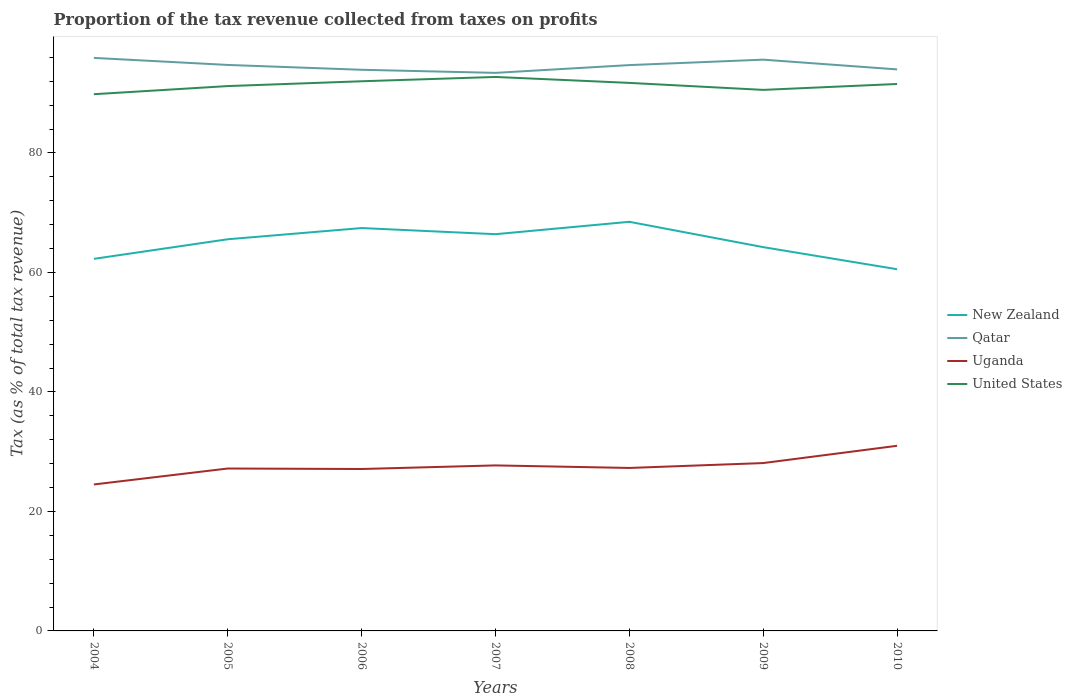How many different coloured lines are there?
Keep it short and to the point. 4. Does the line corresponding to Uganda intersect with the line corresponding to New Zealand?
Make the answer very short. No. Across all years, what is the maximum proportion of the tax revenue collected in Uganda?
Your answer should be very brief. 24.51. What is the total proportion of the tax revenue collected in New Zealand in the graph?
Your answer should be very brief. 1.32. What is the difference between the highest and the second highest proportion of the tax revenue collected in New Zealand?
Make the answer very short. 7.94. What is the difference between the highest and the lowest proportion of the tax revenue collected in Qatar?
Offer a very short reply. 4. How many lines are there?
Provide a short and direct response. 4. How many years are there in the graph?
Ensure brevity in your answer.  7. What is the difference between two consecutive major ticks on the Y-axis?
Offer a terse response. 20. Are the values on the major ticks of Y-axis written in scientific E-notation?
Your answer should be very brief. No. Does the graph contain any zero values?
Your answer should be compact. No. Does the graph contain grids?
Give a very brief answer. No. Where does the legend appear in the graph?
Make the answer very short. Center right. What is the title of the graph?
Ensure brevity in your answer.  Proportion of the tax revenue collected from taxes on profits. Does "Timor-Leste" appear as one of the legend labels in the graph?
Give a very brief answer. No. What is the label or title of the Y-axis?
Your answer should be compact. Tax (as % of total tax revenue). What is the Tax (as % of total tax revenue) in New Zealand in 2004?
Offer a terse response. 62.27. What is the Tax (as % of total tax revenue) in Qatar in 2004?
Keep it short and to the point. 95.9. What is the Tax (as % of total tax revenue) of Uganda in 2004?
Your response must be concise. 24.51. What is the Tax (as % of total tax revenue) of United States in 2004?
Give a very brief answer. 89.83. What is the Tax (as % of total tax revenue) of New Zealand in 2005?
Offer a very short reply. 65.55. What is the Tax (as % of total tax revenue) in Qatar in 2005?
Ensure brevity in your answer.  94.73. What is the Tax (as % of total tax revenue) of Uganda in 2005?
Keep it short and to the point. 27.18. What is the Tax (as % of total tax revenue) in United States in 2005?
Ensure brevity in your answer.  91.19. What is the Tax (as % of total tax revenue) in New Zealand in 2006?
Ensure brevity in your answer.  67.43. What is the Tax (as % of total tax revenue) in Qatar in 2006?
Your response must be concise. 93.92. What is the Tax (as % of total tax revenue) of Uganda in 2006?
Offer a very short reply. 27.1. What is the Tax (as % of total tax revenue) of United States in 2006?
Make the answer very short. 91.99. What is the Tax (as % of total tax revenue) in New Zealand in 2007?
Provide a short and direct response. 66.4. What is the Tax (as % of total tax revenue) of Qatar in 2007?
Give a very brief answer. 93.4. What is the Tax (as % of total tax revenue) of Uganda in 2007?
Give a very brief answer. 27.7. What is the Tax (as % of total tax revenue) in United States in 2007?
Give a very brief answer. 92.71. What is the Tax (as % of total tax revenue) in New Zealand in 2008?
Keep it short and to the point. 68.47. What is the Tax (as % of total tax revenue) in Qatar in 2008?
Ensure brevity in your answer.  94.7. What is the Tax (as % of total tax revenue) of Uganda in 2008?
Offer a very short reply. 27.27. What is the Tax (as % of total tax revenue) of United States in 2008?
Your response must be concise. 91.72. What is the Tax (as % of total tax revenue) of New Zealand in 2009?
Ensure brevity in your answer.  64.23. What is the Tax (as % of total tax revenue) of Qatar in 2009?
Your answer should be very brief. 95.61. What is the Tax (as % of total tax revenue) in Uganda in 2009?
Provide a short and direct response. 28.09. What is the Tax (as % of total tax revenue) in United States in 2009?
Offer a very short reply. 90.55. What is the Tax (as % of total tax revenue) in New Zealand in 2010?
Your response must be concise. 60.53. What is the Tax (as % of total tax revenue) in Qatar in 2010?
Provide a short and direct response. 93.98. What is the Tax (as % of total tax revenue) in Uganda in 2010?
Your answer should be very brief. 30.98. What is the Tax (as % of total tax revenue) in United States in 2010?
Keep it short and to the point. 91.54. Across all years, what is the maximum Tax (as % of total tax revenue) of New Zealand?
Offer a very short reply. 68.47. Across all years, what is the maximum Tax (as % of total tax revenue) of Qatar?
Provide a short and direct response. 95.9. Across all years, what is the maximum Tax (as % of total tax revenue) of Uganda?
Your answer should be very brief. 30.98. Across all years, what is the maximum Tax (as % of total tax revenue) in United States?
Make the answer very short. 92.71. Across all years, what is the minimum Tax (as % of total tax revenue) in New Zealand?
Your answer should be compact. 60.53. Across all years, what is the minimum Tax (as % of total tax revenue) in Qatar?
Give a very brief answer. 93.4. Across all years, what is the minimum Tax (as % of total tax revenue) of Uganda?
Your answer should be compact. 24.51. Across all years, what is the minimum Tax (as % of total tax revenue) in United States?
Your answer should be very brief. 89.83. What is the total Tax (as % of total tax revenue) of New Zealand in the graph?
Offer a very short reply. 454.89. What is the total Tax (as % of total tax revenue) in Qatar in the graph?
Provide a short and direct response. 662.24. What is the total Tax (as % of total tax revenue) in Uganda in the graph?
Your answer should be very brief. 192.85. What is the total Tax (as % of total tax revenue) in United States in the graph?
Your answer should be compact. 639.54. What is the difference between the Tax (as % of total tax revenue) in New Zealand in 2004 and that in 2005?
Your answer should be compact. -3.28. What is the difference between the Tax (as % of total tax revenue) of Qatar in 2004 and that in 2005?
Ensure brevity in your answer.  1.18. What is the difference between the Tax (as % of total tax revenue) of Uganda in 2004 and that in 2005?
Offer a terse response. -2.67. What is the difference between the Tax (as % of total tax revenue) in United States in 2004 and that in 2005?
Make the answer very short. -1.36. What is the difference between the Tax (as % of total tax revenue) in New Zealand in 2004 and that in 2006?
Your answer should be compact. -5.15. What is the difference between the Tax (as % of total tax revenue) in Qatar in 2004 and that in 2006?
Keep it short and to the point. 1.99. What is the difference between the Tax (as % of total tax revenue) in Uganda in 2004 and that in 2006?
Offer a very short reply. -2.59. What is the difference between the Tax (as % of total tax revenue) in United States in 2004 and that in 2006?
Give a very brief answer. -2.17. What is the difference between the Tax (as % of total tax revenue) in New Zealand in 2004 and that in 2007?
Offer a terse response. -4.13. What is the difference between the Tax (as % of total tax revenue) in Qatar in 2004 and that in 2007?
Your answer should be very brief. 2.5. What is the difference between the Tax (as % of total tax revenue) in Uganda in 2004 and that in 2007?
Your answer should be very brief. -3.19. What is the difference between the Tax (as % of total tax revenue) in United States in 2004 and that in 2007?
Your answer should be compact. -2.89. What is the difference between the Tax (as % of total tax revenue) of New Zealand in 2004 and that in 2008?
Provide a short and direct response. -6.2. What is the difference between the Tax (as % of total tax revenue) in Qatar in 2004 and that in 2008?
Give a very brief answer. 1.2. What is the difference between the Tax (as % of total tax revenue) of Uganda in 2004 and that in 2008?
Provide a short and direct response. -2.76. What is the difference between the Tax (as % of total tax revenue) in United States in 2004 and that in 2008?
Give a very brief answer. -1.89. What is the difference between the Tax (as % of total tax revenue) of New Zealand in 2004 and that in 2009?
Offer a terse response. -1.96. What is the difference between the Tax (as % of total tax revenue) in Qatar in 2004 and that in 2009?
Your answer should be compact. 0.29. What is the difference between the Tax (as % of total tax revenue) in Uganda in 2004 and that in 2009?
Provide a short and direct response. -3.58. What is the difference between the Tax (as % of total tax revenue) of United States in 2004 and that in 2009?
Give a very brief answer. -0.72. What is the difference between the Tax (as % of total tax revenue) of New Zealand in 2004 and that in 2010?
Provide a short and direct response. 1.74. What is the difference between the Tax (as % of total tax revenue) of Qatar in 2004 and that in 2010?
Your response must be concise. 1.92. What is the difference between the Tax (as % of total tax revenue) in Uganda in 2004 and that in 2010?
Offer a terse response. -6.47. What is the difference between the Tax (as % of total tax revenue) of United States in 2004 and that in 2010?
Make the answer very short. -1.71. What is the difference between the Tax (as % of total tax revenue) of New Zealand in 2005 and that in 2006?
Your answer should be compact. -1.88. What is the difference between the Tax (as % of total tax revenue) of Qatar in 2005 and that in 2006?
Your response must be concise. 0.81. What is the difference between the Tax (as % of total tax revenue) in Uganda in 2005 and that in 2006?
Your response must be concise. 0.08. What is the difference between the Tax (as % of total tax revenue) of United States in 2005 and that in 2006?
Provide a succinct answer. -0.81. What is the difference between the Tax (as % of total tax revenue) in New Zealand in 2005 and that in 2007?
Make the answer very short. -0.85. What is the difference between the Tax (as % of total tax revenue) in Qatar in 2005 and that in 2007?
Offer a terse response. 1.33. What is the difference between the Tax (as % of total tax revenue) in Uganda in 2005 and that in 2007?
Your answer should be compact. -0.52. What is the difference between the Tax (as % of total tax revenue) in United States in 2005 and that in 2007?
Give a very brief answer. -1.53. What is the difference between the Tax (as % of total tax revenue) of New Zealand in 2005 and that in 2008?
Make the answer very short. -2.92. What is the difference between the Tax (as % of total tax revenue) in Qatar in 2005 and that in 2008?
Your response must be concise. 0.03. What is the difference between the Tax (as % of total tax revenue) of Uganda in 2005 and that in 2008?
Ensure brevity in your answer.  -0.09. What is the difference between the Tax (as % of total tax revenue) of United States in 2005 and that in 2008?
Keep it short and to the point. -0.53. What is the difference between the Tax (as % of total tax revenue) of New Zealand in 2005 and that in 2009?
Make the answer very short. 1.32. What is the difference between the Tax (as % of total tax revenue) in Qatar in 2005 and that in 2009?
Provide a short and direct response. -0.88. What is the difference between the Tax (as % of total tax revenue) in Uganda in 2005 and that in 2009?
Keep it short and to the point. -0.91. What is the difference between the Tax (as % of total tax revenue) in United States in 2005 and that in 2009?
Your answer should be compact. 0.64. What is the difference between the Tax (as % of total tax revenue) in New Zealand in 2005 and that in 2010?
Provide a succinct answer. 5.02. What is the difference between the Tax (as % of total tax revenue) of Qatar in 2005 and that in 2010?
Your answer should be compact. 0.75. What is the difference between the Tax (as % of total tax revenue) of Uganda in 2005 and that in 2010?
Provide a succinct answer. -3.8. What is the difference between the Tax (as % of total tax revenue) of United States in 2005 and that in 2010?
Your answer should be compact. -0.35. What is the difference between the Tax (as % of total tax revenue) in New Zealand in 2006 and that in 2007?
Your answer should be compact. 1.03. What is the difference between the Tax (as % of total tax revenue) of Qatar in 2006 and that in 2007?
Offer a very short reply. 0.52. What is the difference between the Tax (as % of total tax revenue) of Uganda in 2006 and that in 2007?
Make the answer very short. -0.6. What is the difference between the Tax (as % of total tax revenue) in United States in 2006 and that in 2007?
Your answer should be very brief. -0.72. What is the difference between the Tax (as % of total tax revenue) of New Zealand in 2006 and that in 2008?
Provide a succinct answer. -1.05. What is the difference between the Tax (as % of total tax revenue) in Qatar in 2006 and that in 2008?
Ensure brevity in your answer.  -0.78. What is the difference between the Tax (as % of total tax revenue) in Uganda in 2006 and that in 2008?
Give a very brief answer. -0.17. What is the difference between the Tax (as % of total tax revenue) in United States in 2006 and that in 2008?
Your answer should be compact. 0.27. What is the difference between the Tax (as % of total tax revenue) in New Zealand in 2006 and that in 2009?
Give a very brief answer. 3.19. What is the difference between the Tax (as % of total tax revenue) of Qatar in 2006 and that in 2009?
Make the answer very short. -1.69. What is the difference between the Tax (as % of total tax revenue) in Uganda in 2006 and that in 2009?
Make the answer very short. -0.99. What is the difference between the Tax (as % of total tax revenue) in United States in 2006 and that in 2009?
Give a very brief answer. 1.44. What is the difference between the Tax (as % of total tax revenue) in New Zealand in 2006 and that in 2010?
Make the answer very short. 6.89. What is the difference between the Tax (as % of total tax revenue) in Qatar in 2006 and that in 2010?
Your answer should be compact. -0.06. What is the difference between the Tax (as % of total tax revenue) of Uganda in 2006 and that in 2010?
Your answer should be compact. -3.88. What is the difference between the Tax (as % of total tax revenue) of United States in 2006 and that in 2010?
Your answer should be very brief. 0.46. What is the difference between the Tax (as % of total tax revenue) in New Zealand in 2007 and that in 2008?
Ensure brevity in your answer.  -2.07. What is the difference between the Tax (as % of total tax revenue) of Qatar in 2007 and that in 2008?
Ensure brevity in your answer.  -1.3. What is the difference between the Tax (as % of total tax revenue) of Uganda in 2007 and that in 2008?
Offer a terse response. 0.43. What is the difference between the Tax (as % of total tax revenue) of United States in 2007 and that in 2008?
Provide a short and direct response. 0.99. What is the difference between the Tax (as % of total tax revenue) of New Zealand in 2007 and that in 2009?
Ensure brevity in your answer.  2.17. What is the difference between the Tax (as % of total tax revenue) in Qatar in 2007 and that in 2009?
Provide a short and direct response. -2.21. What is the difference between the Tax (as % of total tax revenue) of Uganda in 2007 and that in 2009?
Provide a succinct answer. -0.39. What is the difference between the Tax (as % of total tax revenue) of United States in 2007 and that in 2009?
Offer a very short reply. 2.16. What is the difference between the Tax (as % of total tax revenue) in New Zealand in 2007 and that in 2010?
Provide a short and direct response. 5.87. What is the difference between the Tax (as % of total tax revenue) of Qatar in 2007 and that in 2010?
Provide a short and direct response. -0.58. What is the difference between the Tax (as % of total tax revenue) in Uganda in 2007 and that in 2010?
Your answer should be compact. -3.28. What is the difference between the Tax (as % of total tax revenue) of United States in 2007 and that in 2010?
Offer a terse response. 1.18. What is the difference between the Tax (as % of total tax revenue) of New Zealand in 2008 and that in 2009?
Provide a succinct answer. 4.24. What is the difference between the Tax (as % of total tax revenue) of Qatar in 2008 and that in 2009?
Give a very brief answer. -0.91. What is the difference between the Tax (as % of total tax revenue) of Uganda in 2008 and that in 2009?
Your answer should be compact. -0.82. What is the difference between the Tax (as % of total tax revenue) in United States in 2008 and that in 2009?
Offer a very short reply. 1.17. What is the difference between the Tax (as % of total tax revenue) of New Zealand in 2008 and that in 2010?
Provide a short and direct response. 7.94. What is the difference between the Tax (as % of total tax revenue) in Qatar in 2008 and that in 2010?
Offer a terse response. 0.72. What is the difference between the Tax (as % of total tax revenue) of Uganda in 2008 and that in 2010?
Provide a succinct answer. -3.71. What is the difference between the Tax (as % of total tax revenue) of United States in 2008 and that in 2010?
Offer a very short reply. 0.18. What is the difference between the Tax (as % of total tax revenue) of New Zealand in 2009 and that in 2010?
Your answer should be very brief. 3.7. What is the difference between the Tax (as % of total tax revenue) in Qatar in 2009 and that in 2010?
Your answer should be very brief. 1.63. What is the difference between the Tax (as % of total tax revenue) in Uganda in 2009 and that in 2010?
Provide a short and direct response. -2.89. What is the difference between the Tax (as % of total tax revenue) of United States in 2009 and that in 2010?
Offer a terse response. -0.99. What is the difference between the Tax (as % of total tax revenue) of New Zealand in 2004 and the Tax (as % of total tax revenue) of Qatar in 2005?
Your response must be concise. -32.45. What is the difference between the Tax (as % of total tax revenue) of New Zealand in 2004 and the Tax (as % of total tax revenue) of Uganda in 2005?
Your response must be concise. 35.09. What is the difference between the Tax (as % of total tax revenue) of New Zealand in 2004 and the Tax (as % of total tax revenue) of United States in 2005?
Keep it short and to the point. -28.91. What is the difference between the Tax (as % of total tax revenue) of Qatar in 2004 and the Tax (as % of total tax revenue) of Uganda in 2005?
Provide a short and direct response. 68.72. What is the difference between the Tax (as % of total tax revenue) of Qatar in 2004 and the Tax (as % of total tax revenue) of United States in 2005?
Offer a terse response. 4.72. What is the difference between the Tax (as % of total tax revenue) in Uganda in 2004 and the Tax (as % of total tax revenue) in United States in 2005?
Offer a very short reply. -66.68. What is the difference between the Tax (as % of total tax revenue) in New Zealand in 2004 and the Tax (as % of total tax revenue) in Qatar in 2006?
Provide a succinct answer. -31.64. What is the difference between the Tax (as % of total tax revenue) of New Zealand in 2004 and the Tax (as % of total tax revenue) of Uganda in 2006?
Give a very brief answer. 35.17. What is the difference between the Tax (as % of total tax revenue) in New Zealand in 2004 and the Tax (as % of total tax revenue) in United States in 2006?
Offer a terse response. -29.72. What is the difference between the Tax (as % of total tax revenue) of Qatar in 2004 and the Tax (as % of total tax revenue) of Uganda in 2006?
Provide a succinct answer. 68.8. What is the difference between the Tax (as % of total tax revenue) in Qatar in 2004 and the Tax (as % of total tax revenue) in United States in 2006?
Give a very brief answer. 3.91. What is the difference between the Tax (as % of total tax revenue) in Uganda in 2004 and the Tax (as % of total tax revenue) in United States in 2006?
Your response must be concise. -67.48. What is the difference between the Tax (as % of total tax revenue) in New Zealand in 2004 and the Tax (as % of total tax revenue) in Qatar in 2007?
Provide a short and direct response. -31.13. What is the difference between the Tax (as % of total tax revenue) of New Zealand in 2004 and the Tax (as % of total tax revenue) of Uganda in 2007?
Your response must be concise. 34.57. What is the difference between the Tax (as % of total tax revenue) in New Zealand in 2004 and the Tax (as % of total tax revenue) in United States in 2007?
Your answer should be very brief. -30.44. What is the difference between the Tax (as % of total tax revenue) of Qatar in 2004 and the Tax (as % of total tax revenue) of Uganda in 2007?
Provide a succinct answer. 68.2. What is the difference between the Tax (as % of total tax revenue) in Qatar in 2004 and the Tax (as % of total tax revenue) in United States in 2007?
Provide a succinct answer. 3.19. What is the difference between the Tax (as % of total tax revenue) of Uganda in 2004 and the Tax (as % of total tax revenue) of United States in 2007?
Offer a very short reply. -68.2. What is the difference between the Tax (as % of total tax revenue) in New Zealand in 2004 and the Tax (as % of total tax revenue) in Qatar in 2008?
Provide a succinct answer. -32.43. What is the difference between the Tax (as % of total tax revenue) of New Zealand in 2004 and the Tax (as % of total tax revenue) of Uganda in 2008?
Your answer should be very brief. 35. What is the difference between the Tax (as % of total tax revenue) in New Zealand in 2004 and the Tax (as % of total tax revenue) in United States in 2008?
Ensure brevity in your answer.  -29.45. What is the difference between the Tax (as % of total tax revenue) of Qatar in 2004 and the Tax (as % of total tax revenue) of Uganda in 2008?
Make the answer very short. 68.63. What is the difference between the Tax (as % of total tax revenue) of Qatar in 2004 and the Tax (as % of total tax revenue) of United States in 2008?
Make the answer very short. 4.18. What is the difference between the Tax (as % of total tax revenue) in Uganda in 2004 and the Tax (as % of total tax revenue) in United States in 2008?
Provide a short and direct response. -67.21. What is the difference between the Tax (as % of total tax revenue) of New Zealand in 2004 and the Tax (as % of total tax revenue) of Qatar in 2009?
Offer a very short reply. -33.34. What is the difference between the Tax (as % of total tax revenue) in New Zealand in 2004 and the Tax (as % of total tax revenue) in Uganda in 2009?
Your answer should be very brief. 34.18. What is the difference between the Tax (as % of total tax revenue) of New Zealand in 2004 and the Tax (as % of total tax revenue) of United States in 2009?
Ensure brevity in your answer.  -28.28. What is the difference between the Tax (as % of total tax revenue) of Qatar in 2004 and the Tax (as % of total tax revenue) of Uganda in 2009?
Offer a terse response. 67.81. What is the difference between the Tax (as % of total tax revenue) in Qatar in 2004 and the Tax (as % of total tax revenue) in United States in 2009?
Your response must be concise. 5.35. What is the difference between the Tax (as % of total tax revenue) of Uganda in 2004 and the Tax (as % of total tax revenue) of United States in 2009?
Ensure brevity in your answer.  -66.04. What is the difference between the Tax (as % of total tax revenue) of New Zealand in 2004 and the Tax (as % of total tax revenue) of Qatar in 2010?
Keep it short and to the point. -31.71. What is the difference between the Tax (as % of total tax revenue) in New Zealand in 2004 and the Tax (as % of total tax revenue) in Uganda in 2010?
Keep it short and to the point. 31.29. What is the difference between the Tax (as % of total tax revenue) in New Zealand in 2004 and the Tax (as % of total tax revenue) in United States in 2010?
Give a very brief answer. -29.26. What is the difference between the Tax (as % of total tax revenue) in Qatar in 2004 and the Tax (as % of total tax revenue) in Uganda in 2010?
Make the answer very short. 64.92. What is the difference between the Tax (as % of total tax revenue) in Qatar in 2004 and the Tax (as % of total tax revenue) in United States in 2010?
Your response must be concise. 4.37. What is the difference between the Tax (as % of total tax revenue) of Uganda in 2004 and the Tax (as % of total tax revenue) of United States in 2010?
Provide a succinct answer. -67.03. What is the difference between the Tax (as % of total tax revenue) in New Zealand in 2005 and the Tax (as % of total tax revenue) in Qatar in 2006?
Keep it short and to the point. -28.37. What is the difference between the Tax (as % of total tax revenue) of New Zealand in 2005 and the Tax (as % of total tax revenue) of Uganda in 2006?
Provide a short and direct response. 38.45. What is the difference between the Tax (as % of total tax revenue) of New Zealand in 2005 and the Tax (as % of total tax revenue) of United States in 2006?
Give a very brief answer. -26.44. What is the difference between the Tax (as % of total tax revenue) in Qatar in 2005 and the Tax (as % of total tax revenue) in Uganda in 2006?
Provide a short and direct response. 67.63. What is the difference between the Tax (as % of total tax revenue) in Qatar in 2005 and the Tax (as % of total tax revenue) in United States in 2006?
Your answer should be very brief. 2.73. What is the difference between the Tax (as % of total tax revenue) in Uganda in 2005 and the Tax (as % of total tax revenue) in United States in 2006?
Provide a short and direct response. -64.81. What is the difference between the Tax (as % of total tax revenue) in New Zealand in 2005 and the Tax (as % of total tax revenue) in Qatar in 2007?
Your answer should be very brief. -27.85. What is the difference between the Tax (as % of total tax revenue) of New Zealand in 2005 and the Tax (as % of total tax revenue) of Uganda in 2007?
Keep it short and to the point. 37.85. What is the difference between the Tax (as % of total tax revenue) of New Zealand in 2005 and the Tax (as % of total tax revenue) of United States in 2007?
Give a very brief answer. -27.16. What is the difference between the Tax (as % of total tax revenue) of Qatar in 2005 and the Tax (as % of total tax revenue) of Uganda in 2007?
Your answer should be compact. 67.03. What is the difference between the Tax (as % of total tax revenue) in Qatar in 2005 and the Tax (as % of total tax revenue) in United States in 2007?
Give a very brief answer. 2.01. What is the difference between the Tax (as % of total tax revenue) in Uganda in 2005 and the Tax (as % of total tax revenue) in United States in 2007?
Your answer should be very brief. -65.53. What is the difference between the Tax (as % of total tax revenue) of New Zealand in 2005 and the Tax (as % of total tax revenue) of Qatar in 2008?
Your answer should be very brief. -29.15. What is the difference between the Tax (as % of total tax revenue) in New Zealand in 2005 and the Tax (as % of total tax revenue) in Uganda in 2008?
Offer a very short reply. 38.28. What is the difference between the Tax (as % of total tax revenue) of New Zealand in 2005 and the Tax (as % of total tax revenue) of United States in 2008?
Offer a terse response. -26.17. What is the difference between the Tax (as % of total tax revenue) of Qatar in 2005 and the Tax (as % of total tax revenue) of Uganda in 2008?
Give a very brief answer. 67.45. What is the difference between the Tax (as % of total tax revenue) in Qatar in 2005 and the Tax (as % of total tax revenue) in United States in 2008?
Your answer should be compact. 3. What is the difference between the Tax (as % of total tax revenue) in Uganda in 2005 and the Tax (as % of total tax revenue) in United States in 2008?
Ensure brevity in your answer.  -64.54. What is the difference between the Tax (as % of total tax revenue) of New Zealand in 2005 and the Tax (as % of total tax revenue) of Qatar in 2009?
Make the answer very short. -30.06. What is the difference between the Tax (as % of total tax revenue) in New Zealand in 2005 and the Tax (as % of total tax revenue) in Uganda in 2009?
Ensure brevity in your answer.  37.46. What is the difference between the Tax (as % of total tax revenue) of New Zealand in 2005 and the Tax (as % of total tax revenue) of United States in 2009?
Your response must be concise. -25. What is the difference between the Tax (as % of total tax revenue) in Qatar in 2005 and the Tax (as % of total tax revenue) in Uganda in 2009?
Provide a short and direct response. 66.63. What is the difference between the Tax (as % of total tax revenue) in Qatar in 2005 and the Tax (as % of total tax revenue) in United States in 2009?
Your answer should be very brief. 4.18. What is the difference between the Tax (as % of total tax revenue) of Uganda in 2005 and the Tax (as % of total tax revenue) of United States in 2009?
Your response must be concise. -63.37. What is the difference between the Tax (as % of total tax revenue) of New Zealand in 2005 and the Tax (as % of total tax revenue) of Qatar in 2010?
Offer a very short reply. -28.43. What is the difference between the Tax (as % of total tax revenue) of New Zealand in 2005 and the Tax (as % of total tax revenue) of Uganda in 2010?
Your answer should be compact. 34.57. What is the difference between the Tax (as % of total tax revenue) of New Zealand in 2005 and the Tax (as % of total tax revenue) of United States in 2010?
Give a very brief answer. -25.99. What is the difference between the Tax (as % of total tax revenue) in Qatar in 2005 and the Tax (as % of total tax revenue) in Uganda in 2010?
Give a very brief answer. 63.74. What is the difference between the Tax (as % of total tax revenue) of Qatar in 2005 and the Tax (as % of total tax revenue) of United States in 2010?
Keep it short and to the point. 3.19. What is the difference between the Tax (as % of total tax revenue) of Uganda in 2005 and the Tax (as % of total tax revenue) of United States in 2010?
Ensure brevity in your answer.  -64.36. What is the difference between the Tax (as % of total tax revenue) in New Zealand in 2006 and the Tax (as % of total tax revenue) in Qatar in 2007?
Provide a succinct answer. -25.97. What is the difference between the Tax (as % of total tax revenue) in New Zealand in 2006 and the Tax (as % of total tax revenue) in Uganda in 2007?
Make the answer very short. 39.72. What is the difference between the Tax (as % of total tax revenue) in New Zealand in 2006 and the Tax (as % of total tax revenue) in United States in 2007?
Ensure brevity in your answer.  -25.29. What is the difference between the Tax (as % of total tax revenue) of Qatar in 2006 and the Tax (as % of total tax revenue) of Uganda in 2007?
Your response must be concise. 66.22. What is the difference between the Tax (as % of total tax revenue) of Qatar in 2006 and the Tax (as % of total tax revenue) of United States in 2007?
Provide a succinct answer. 1.2. What is the difference between the Tax (as % of total tax revenue) of Uganda in 2006 and the Tax (as % of total tax revenue) of United States in 2007?
Your response must be concise. -65.61. What is the difference between the Tax (as % of total tax revenue) in New Zealand in 2006 and the Tax (as % of total tax revenue) in Qatar in 2008?
Ensure brevity in your answer.  -27.27. What is the difference between the Tax (as % of total tax revenue) of New Zealand in 2006 and the Tax (as % of total tax revenue) of Uganda in 2008?
Keep it short and to the point. 40.15. What is the difference between the Tax (as % of total tax revenue) of New Zealand in 2006 and the Tax (as % of total tax revenue) of United States in 2008?
Make the answer very short. -24.3. What is the difference between the Tax (as % of total tax revenue) in Qatar in 2006 and the Tax (as % of total tax revenue) in Uganda in 2008?
Give a very brief answer. 66.64. What is the difference between the Tax (as % of total tax revenue) in Qatar in 2006 and the Tax (as % of total tax revenue) in United States in 2008?
Your answer should be very brief. 2.19. What is the difference between the Tax (as % of total tax revenue) of Uganda in 2006 and the Tax (as % of total tax revenue) of United States in 2008?
Your response must be concise. -64.62. What is the difference between the Tax (as % of total tax revenue) in New Zealand in 2006 and the Tax (as % of total tax revenue) in Qatar in 2009?
Provide a succinct answer. -28.18. What is the difference between the Tax (as % of total tax revenue) in New Zealand in 2006 and the Tax (as % of total tax revenue) in Uganda in 2009?
Give a very brief answer. 39.33. What is the difference between the Tax (as % of total tax revenue) of New Zealand in 2006 and the Tax (as % of total tax revenue) of United States in 2009?
Provide a short and direct response. -23.12. What is the difference between the Tax (as % of total tax revenue) of Qatar in 2006 and the Tax (as % of total tax revenue) of Uganda in 2009?
Ensure brevity in your answer.  65.82. What is the difference between the Tax (as % of total tax revenue) of Qatar in 2006 and the Tax (as % of total tax revenue) of United States in 2009?
Your response must be concise. 3.37. What is the difference between the Tax (as % of total tax revenue) of Uganda in 2006 and the Tax (as % of total tax revenue) of United States in 2009?
Provide a short and direct response. -63.45. What is the difference between the Tax (as % of total tax revenue) in New Zealand in 2006 and the Tax (as % of total tax revenue) in Qatar in 2010?
Offer a very short reply. -26.55. What is the difference between the Tax (as % of total tax revenue) in New Zealand in 2006 and the Tax (as % of total tax revenue) in Uganda in 2010?
Your answer should be very brief. 36.44. What is the difference between the Tax (as % of total tax revenue) of New Zealand in 2006 and the Tax (as % of total tax revenue) of United States in 2010?
Make the answer very short. -24.11. What is the difference between the Tax (as % of total tax revenue) of Qatar in 2006 and the Tax (as % of total tax revenue) of Uganda in 2010?
Ensure brevity in your answer.  62.93. What is the difference between the Tax (as % of total tax revenue) of Qatar in 2006 and the Tax (as % of total tax revenue) of United States in 2010?
Keep it short and to the point. 2.38. What is the difference between the Tax (as % of total tax revenue) of Uganda in 2006 and the Tax (as % of total tax revenue) of United States in 2010?
Offer a terse response. -64.44. What is the difference between the Tax (as % of total tax revenue) in New Zealand in 2007 and the Tax (as % of total tax revenue) in Qatar in 2008?
Offer a very short reply. -28.3. What is the difference between the Tax (as % of total tax revenue) in New Zealand in 2007 and the Tax (as % of total tax revenue) in Uganda in 2008?
Provide a succinct answer. 39.12. What is the difference between the Tax (as % of total tax revenue) in New Zealand in 2007 and the Tax (as % of total tax revenue) in United States in 2008?
Your answer should be compact. -25.32. What is the difference between the Tax (as % of total tax revenue) in Qatar in 2007 and the Tax (as % of total tax revenue) in Uganda in 2008?
Provide a short and direct response. 66.13. What is the difference between the Tax (as % of total tax revenue) of Qatar in 2007 and the Tax (as % of total tax revenue) of United States in 2008?
Offer a very short reply. 1.68. What is the difference between the Tax (as % of total tax revenue) in Uganda in 2007 and the Tax (as % of total tax revenue) in United States in 2008?
Offer a very short reply. -64.02. What is the difference between the Tax (as % of total tax revenue) in New Zealand in 2007 and the Tax (as % of total tax revenue) in Qatar in 2009?
Give a very brief answer. -29.21. What is the difference between the Tax (as % of total tax revenue) of New Zealand in 2007 and the Tax (as % of total tax revenue) of Uganda in 2009?
Your answer should be compact. 38.3. What is the difference between the Tax (as % of total tax revenue) in New Zealand in 2007 and the Tax (as % of total tax revenue) in United States in 2009?
Your answer should be compact. -24.15. What is the difference between the Tax (as % of total tax revenue) in Qatar in 2007 and the Tax (as % of total tax revenue) in Uganda in 2009?
Ensure brevity in your answer.  65.31. What is the difference between the Tax (as % of total tax revenue) in Qatar in 2007 and the Tax (as % of total tax revenue) in United States in 2009?
Provide a short and direct response. 2.85. What is the difference between the Tax (as % of total tax revenue) of Uganda in 2007 and the Tax (as % of total tax revenue) of United States in 2009?
Offer a terse response. -62.85. What is the difference between the Tax (as % of total tax revenue) in New Zealand in 2007 and the Tax (as % of total tax revenue) in Qatar in 2010?
Offer a terse response. -27.58. What is the difference between the Tax (as % of total tax revenue) of New Zealand in 2007 and the Tax (as % of total tax revenue) of Uganda in 2010?
Offer a very short reply. 35.42. What is the difference between the Tax (as % of total tax revenue) in New Zealand in 2007 and the Tax (as % of total tax revenue) in United States in 2010?
Keep it short and to the point. -25.14. What is the difference between the Tax (as % of total tax revenue) of Qatar in 2007 and the Tax (as % of total tax revenue) of Uganda in 2010?
Your answer should be very brief. 62.42. What is the difference between the Tax (as % of total tax revenue) in Qatar in 2007 and the Tax (as % of total tax revenue) in United States in 2010?
Your answer should be very brief. 1.86. What is the difference between the Tax (as % of total tax revenue) in Uganda in 2007 and the Tax (as % of total tax revenue) in United States in 2010?
Ensure brevity in your answer.  -63.84. What is the difference between the Tax (as % of total tax revenue) in New Zealand in 2008 and the Tax (as % of total tax revenue) in Qatar in 2009?
Offer a very short reply. -27.14. What is the difference between the Tax (as % of total tax revenue) in New Zealand in 2008 and the Tax (as % of total tax revenue) in Uganda in 2009?
Your response must be concise. 40.38. What is the difference between the Tax (as % of total tax revenue) in New Zealand in 2008 and the Tax (as % of total tax revenue) in United States in 2009?
Provide a short and direct response. -22.08. What is the difference between the Tax (as % of total tax revenue) of Qatar in 2008 and the Tax (as % of total tax revenue) of Uganda in 2009?
Your response must be concise. 66.61. What is the difference between the Tax (as % of total tax revenue) in Qatar in 2008 and the Tax (as % of total tax revenue) in United States in 2009?
Give a very brief answer. 4.15. What is the difference between the Tax (as % of total tax revenue) of Uganda in 2008 and the Tax (as % of total tax revenue) of United States in 2009?
Keep it short and to the point. -63.28. What is the difference between the Tax (as % of total tax revenue) of New Zealand in 2008 and the Tax (as % of total tax revenue) of Qatar in 2010?
Your response must be concise. -25.51. What is the difference between the Tax (as % of total tax revenue) of New Zealand in 2008 and the Tax (as % of total tax revenue) of Uganda in 2010?
Your answer should be compact. 37.49. What is the difference between the Tax (as % of total tax revenue) of New Zealand in 2008 and the Tax (as % of total tax revenue) of United States in 2010?
Make the answer very short. -23.06. What is the difference between the Tax (as % of total tax revenue) of Qatar in 2008 and the Tax (as % of total tax revenue) of Uganda in 2010?
Provide a succinct answer. 63.72. What is the difference between the Tax (as % of total tax revenue) of Qatar in 2008 and the Tax (as % of total tax revenue) of United States in 2010?
Provide a succinct answer. 3.16. What is the difference between the Tax (as % of total tax revenue) in Uganda in 2008 and the Tax (as % of total tax revenue) in United States in 2010?
Provide a succinct answer. -64.26. What is the difference between the Tax (as % of total tax revenue) in New Zealand in 2009 and the Tax (as % of total tax revenue) in Qatar in 2010?
Provide a succinct answer. -29.75. What is the difference between the Tax (as % of total tax revenue) of New Zealand in 2009 and the Tax (as % of total tax revenue) of Uganda in 2010?
Your answer should be very brief. 33.25. What is the difference between the Tax (as % of total tax revenue) in New Zealand in 2009 and the Tax (as % of total tax revenue) in United States in 2010?
Offer a very short reply. -27.31. What is the difference between the Tax (as % of total tax revenue) in Qatar in 2009 and the Tax (as % of total tax revenue) in Uganda in 2010?
Provide a short and direct response. 64.63. What is the difference between the Tax (as % of total tax revenue) in Qatar in 2009 and the Tax (as % of total tax revenue) in United States in 2010?
Your answer should be compact. 4.07. What is the difference between the Tax (as % of total tax revenue) in Uganda in 2009 and the Tax (as % of total tax revenue) in United States in 2010?
Your answer should be very brief. -63.44. What is the average Tax (as % of total tax revenue) in New Zealand per year?
Ensure brevity in your answer.  64.98. What is the average Tax (as % of total tax revenue) of Qatar per year?
Make the answer very short. 94.61. What is the average Tax (as % of total tax revenue) in Uganda per year?
Keep it short and to the point. 27.55. What is the average Tax (as % of total tax revenue) of United States per year?
Make the answer very short. 91.36. In the year 2004, what is the difference between the Tax (as % of total tax revenue) of New Zealand and Tax (as % of total tax revenue) of Qatar?
Your response must be concise. -33.63. In the year 2004, what is the difference between the Tax (as % of total tax revenue) in New Zealand and Tax (as % of total tax revenue) in Uganda?
Your answer should be very brief. 37.76. In the year 2004, what is the difference between the Tax (as % of total tax revenue) of New Zealand and Tax (as % of total tax revenue) of United States?
Your answer should be very brief. -27.55. In the year 2004, what is the difference between the Tax (as % of total tax revenue) of Qatar and Tax (as % of total tax revenue) of Uganda?
Make the answer very short. 71.39. In the year 2004, what is the difference between the Tax (as % of total tax revenue) of Qatar and Tax (as % of total tax revenue) of United States?
Your answer should be compact. 6.08. In the year 2004, what is the difference between the Tax (as % of total tax revenue) in Uganda and Tax (as % of total tax revenue) in United States?
Provide a short and direct response. -65.32. In the year 2005, what is the difference between the Tax (as % of total tax revenue) in New Zealand and Tax (as % of total tax revenue) in Qatar?
Ensure brevity in your answer.  -29.18. In the year 2005, what is the difference between the Tax (as % of total tax revenue) in New Zealand and Tax (as % of total tax revenue) in Uganda?
Provide a short and direct response. 38.37. In the year 2005, what is the difference between the Tax (as % of total tax revenue) in New Zealand and Tax (as % of total tax revenue) in United States?
Provide a short and direct response. -25.64. In the year 2005, what is the difference between the Tax (as % of total tax revenue) of Qatar and Tax (as % of total tax revenue) of Uganda?
Make the answer very short. 67.55. In the year 2005, what is the difference between the Tax (as % of total tax revenue) of Qatar and Tax (as % of total tax revenue) of United States?
Your answer should be very brief. 3.54. In the year 2005, what is the difference between the Tax (as % of total tax revenue) of Uganda and Tax (as % of total tax revenue) of United States?
Provide a succinct answer. -64.01. In the year 2006, what is the difference between the Tax (as % of total tax revenue) of New Zealand and Tax (as % of total tax revenue) of Qatar?
Offer a very short reply. -26.49. In the year 2006, what is the difference between the Tax (as % of total tax revenue) in New Zealand and Tax (as % of total tax revenue) in Uganda?
Provide a short and direct response. 40.33. In the year 2006, what is the difference between the Tax (as % of total tax revenue) of New Zealand and Tax (as % of total tax revenue) of United States?
Give a very brief answer. -24.57. In the year 2006, what is the difference between the Tax (as % of total tax revenue) in Qatar and Tax (as % of total tax revenue) in Uganda?
Offer a terse response. 66.82. In the year 2006, what is the difference between the Tax (as % of total tax revenue) in Qatar and Tax (as % of total tax revenue) in United States?
Provide a succinct answer. 1.92. In the year 2006, what is the difference between the Tax (as % of total tax revenue) in Uganda and Tax (as % of total tax revenue) in United States?
Your answer should be very brief. -64.89. In the year 2007, what is the difference between the Tax (as % of total tax revenue) in New Zealand and Tax (as % of total tax revenue) in Qatar?
Keep it short and to the point. -27. In the year 2007, what is the difference between the Tax (as % of total tax revenue) of New Zealand and Tax (as % of total tax revenue) of Uganda?
Give a very brief answer. 38.7. In the year 2007, what is the difference between the Tax (as % of total tax revenue) in New Zealand and Tax (as % of total tax revenue) in United States?
Offer a terse response. -26.32. In the year 2007, what is the difference between the Tax (as % of total tax revenue) of Qatar and Tax (as % of total tax revenue) of Uganda?
Ensure brevity in your answer.  65.7. In the year 2007, what is the difference between the Tax (as % of total tax revenue) of Qatar and Tax (as % of total tax revenue) of United States?
Give a very brief answer. 0.69. In the year 2007, what is the difference between the Tax (as % of total tax revenue) of Uganda and Tax (as % of total tax revenue) of United States?
Your answer should be very brief. -65.01. In the year 2008, what is the difference between the Tax (as % of total tax revenue) in New Zealand and Tax (as % of total tax revenue) in Qatar?
Offer a terse response. -26.23. In the year 2008, what is the difference between the Tax (as % of total tax revenue) in New Zealand and Tax (as % of total tax revenue) in Uganda?
Provide a succinct answer. 41.2. In the year 2008, what is the difference between the Tax (as % of total tax revenue) in New Zealand and Tax (as % of total tax revenue) in United States?
Offer a terse response. -23.25. In the year 2008, what is the difference between the Tax (as % of total tax revenue) in Qatar and Tax (as % of total tax revenue) in Uganda?
Give a very brief answer. 67.43. In the year 2008, what is the difference between the Tax (as % of total tax revenue) in Qatar and Tax (as % of total tax revenue) in United States?
Ensure brevity in your answer.  2.98. In the year 2008, what is the difference between the Tax (as % of total tax revenue) in Uganda and Tax (as % of total tax revenue) in United States?
Offer a terse response. -64.45. In the year 2009, what is the difference between the Tax (as % of total tax revenue) in New Zealand and Tax (as % of total tax revenue) in Qatar?
Your response must be concise. -31.38. In the year 2009, what is the difference between the Tax (as % of total tax revenue) of New Zealand and Tax (as % of total tax revenue) of Uganda?
Keep it short and to the point. 36.14. In the year 2009, what is the difference between the Tax (as % of total tax revenue) of New Zealand and Tax (as % of total tax revenue) of United States?
Give a very brief answer. -26.32. In the year 2009, what is the difference between the Tax (as % of total tax revenue) in Qatar and Tax (as % of total tax revenue) in Uganda?
Give a very brief answer. 67.51. In the year 2009, what is the difference between the Tax (as % of total tax revenue) in Qatar and Tax (as % of total tax revenue) in United States?
Your answer should be compact. 5.06. In the year 2009, what is the difference between the Tax (as % of total tax revenue) in Uganda and Tax (as % of total tax revenue) in United States?
Your answer should be compact. -62.46. In the year 2010, what is the difference between the Tax (as % of total tax revenue) of New Zealand and Tax (as % of total tax revenue) of Qatar?
Make the answer very short. -33.44. In the year 2010, what is the difference between the Tax (as % of total tax revenue) in New Zealand and Tax (as % of total tax revenue) in Uganda?
Your answer should be compact. 29.55. In the year 2010, what is the difference between the Tax (as % of total tax revenue) of New Zealand and Tax (as % of total tax revenue) of United States?
Provide a short and direct response. -31. In the year 2010, what is the difference between the Tax (as % of total tax revenue) of Qatar and Tax (as % of total tax revenue) of Uganda?
Keep it short and to the point. 63. In the year 2010, what is the difference between the Tax (as % of total tax revenue) in Qatar and Tax (as % of total tax revenue) in United States?
Keep it short and to the point. 2.44. In the year 2010, what is the difference between the Tax (as % of total tax revenue) of Uganda and Tax (as % of total tax revenue) of United States?
Offer a terse response. -60.55. What is the ratio of the Tax (as % of total tax revenue) in New Zealand in 2004 to that in 2005?
Ensure brevity in your answer.  0.95. What is the ratio of the Tax (as % of total tax revenue) of Qatar in 2004 to that in 2005?
Make the answer very short. 1.01. What is the ratio of the Tax (as % of total tax revenue) in Uganda in 2004 to that in 2005?
Keep it short and to the point. 0.9. What is the ratio of the Tax (as % of total tax revenue) of United States in 2004 to that in 2005?
Your answer should be very brief. 0.99. What is the ratio of the Tax (as % of total tax revenue) in New Zealand in 2004 to that in 2006?
Ensure brevity in your answer.  0.92. What is the ratio of the Tax (as % of total tax revenue) of Qatar in 2004 to that in 2006?
Offer a terse response. 1.02. What is the ratio of the Tax (as % of total tax revenue) of Uganda in 2004 to that in 2006?
Your response must be concise. 0.9. What is the ratio of the Tax (as % of total tax revenue) in United States in 2004 to that in 2006?
Give a very brief answer. 0.98. What is the ratio of the Tax (as % of total tax revenue) in New Zealand in 2004 to that in 2007?
Provide a short and direct response. 0.94. What is the ratio of the Tax (as % of total tax revenue) of Qatar in 2004 to that in 2007?
Your response must be concise. 1.03. What is the ratio of the Tax (as % of total tax revenue) in Uganda in 2004 to that in 2007?
Provide a short and direct response. 0.88. What is the ratio of the Tax (as % of total tax revenue) in United States in 2004 to that in 2007?
Your answer should be compact. 0.97. What is the ratio of the Tax (as % of total tax revenue) of New Zealand in 2004 to that in 2008?
Make the answer very short. 0.91. What is the ratio of the Tax (as % of total tax revenue) in Qatar in 2004 to that in 2008?
Offer a very short reply. 1.01. What is the ratio of the Tax (as % of total tax revenue) of Uganda in 2004 to that in 2008?
Your answer should be very brief. 0.9. What is the ratio of the Tax (as % of total tax revenue) of United States in 2004 to that in 2008?
Ensure brevity in your answer.  0.98. What is the ratio of the Tax (as % of total tax revenue) of New Zealand in 2004 to that in 2009?
Your answer should be compact. 0.97. What is the ratio of the Tax (as % of total tax revenue) in Uganda in 2004 to that in 2009?
Provide a succinct answer. 0.87. What is the ratio of the Tax (as % of total tax revenue) of United States in 2004 to that in 2009?
Your answer should be very brief. 0.99. What is the ratio of the Tax (as % of total tax revenue) of New Zealand in 2004 to that in 2010?
Your answer should be compact. 1.03. What is the ratio of the Tax (as % of total tax revenue) of Qatar in 2004 to that in 2010?
Make the answer very short. 1.02. What is the ratio of the Tax (as % of total tax revenue) of Uganda in 2004 to that in 2010?
Provide a short and direct response. 0.79. What is the ratio of the Tax (as % of total tax revenue) of United States in 2004 to that in 2010?
Give a very brief answer. 0.98. What is the ratio of the Tax (as % of total tax revenue) of New Zealand in 2005 to that in 2006?
Make the answer very short. 0.97. What is the ratio of the Tax (as % of total tax revenue) of Qatar in 2005 to that in 2006?
Your answer should be compact. 1.01. What is the ratio of the Tax (as % of total tax revenue) of Uganda in 2005 to that in 2006?
Your answer should be very brief. 1. What is the ratio of the Tax (as % of total tax revenue) of United States in 2005 to that in 2006?
Your response must be concise. 0.99. What is the ratio of the Tax (as % of total tax revenue) of New Zealand in 2005 to that in 2007?
Give a very brief answer. 0.99. What is the ratio of the Tax (as % of total tax revenue) in Qatar in 2005 to that in 2007?
Your answer should be very brief. 1.01. What is the ratio of the Tax (as % of total tax revenue) of Uganda in 2005 to that in 2007?
Provide a short and direct response. 0.98. What is the ratio of the Tax (as % of total tax revenue) of United States in 2005 to that in 2007?
Your answer should be very brief. 0.98. What is the ratio of the Tax (as % of total tax revenue) in New Zealand in 2005 to that in 2008?
Give a very brief answer. 0.96. What is the ratio of the Tax (as % of total tax revenue) of New Zealand in 2005 to that in 2009?
Offer a very short reply. 1.02. What is the ratio of the Tax (as % of total tax revenue) of Qatar in 2005 to that in 2009?
Your answer should be compact. 0.99. What is the ratio of the Tax (as % of total tax revenue) of Uganda in 2005 to that in 2009?
Ensure brevity in your answer.  0.97. What is the ratio of the Tax (as % of total tax revenue) of New Zealand in 2005 to that in 2010?
Your answer should be compact. 1.08. What is the ratio of the Tax (as % of total tax revenue) in Qatar in 2005 to that in 2010?
Provide a short and direct response. 1.01. What is the ratio of the Tax (as % of total tax revenue) of Uganda in 2005 to that in 2010?
Your answer should be very brief. 0.88. What is the ratio of the Tax (as % of total tax revenue) in New Zealand in 2006 to that in 2007?
Your response must be concise. 1.02. What is the ratio of the Tax (as % of total tax revenue) of Qatar in 2006 to that in 2007?
Keep it short and to the point. 1.01. What is the ratio of the Tax (as % of total tax revenue) in Uganda in 2006 to that in 2007?
Make the answer very short. 0.98. What is the ratio of the Tax (as % of total tax revenue) in New Zealand in 2006 to that in 2008?
Provide a short and direct response. 0.98. What is the ratio of the Tax (as % of total tax revenue) in Uganda in 2006 to that in 2008?
Give a very brief answer. 0.99. What is the ratio of the Tax (as % of total tax revenue) of New Zealand in 2006 to that in 2009?
Ensure brevity in your answer.  1.05. What is the ratio of the Tax (as % of total tax revenue) of Qatar in 2006 to that in 2009?
Your answer should be very brief. 0.98. What is the ratio of the Tax (as % of total tax revenue) of Uganda in 2006 to that in 2009?
Offer a terse response. 0.96. What is the ratio of the Tax (as % of total tax revenue) of United States in 2006 to that in 2009?
Your response must be concise. 1.02. What is the ratio of the Tax (as % of total tax revenue) of New Zealand in 2006 to that in 2010?
Ensure brevity in your answer.  1.11. What is the ratio of the Tax (as % of total tax revenue) in Qatar in 2006 to that in 2010?
Ensure brevity in your answer.  1. What is the ratio of the Tax (as % of total tax revenue) in Uganda in 2006 to that in 2010?
Provide a succinct answer. 0.87. What is the ratio of the Tax (as % of total tax revenue) of New Zealand in 2007 to that in 2008?
Your answer should be compact. 0.97. What is the ratio of the Tax (as % of total tax revenue) of Qatar in 2007 to that in 2008?
Give a very brief answer. 0.99. What is the ratio of the Tax (as % of total tax revenue) in Uganda in 2007 to that in 2008?
Your answer should be very brief. 1.02. What is the ratio of the Tax (as % of total tax revenue) of United States in 2007 to that in 2008?
Your response must be concise. 1.01. What is the ratio of the Tax (as % of total tax revenue) in New Zealand in 2007 to that in 2009?
Give a very brief answer. 1.03. What is the ratio of the Tax (as % of total tax revenue) of Qatar in 2007 to that in 2009?
Ensure brevity in your answer.  0.98. What is the ratio of the Tax (as % of total tax revenue) of United States in 2007 to that in 2009?
Your response must be concise. 1.02. What is the ratio of the Tax (as % of total tax revenue) in New Zealand in 2007 to that in 2010?
Provide a succinct answer. 1.1. What is the ratio of the Tax (as % of total tax revenue) in Qatar in 2007 to that in 2010?
Your answer should be very brief. 0.99. What is the ratio of the Tax (as % of total tax revenue) in Uganda in 2007 to that in 2010?
Give a very brief answer. 0.89. What is the ratio of the Tax (as % of total tax revenue) of United States in 2007 to that in 2010?
Your response must be concise. 1.01. What is the ratio of the Tax (as % of total tax revenue) in New Zealand in 2008 to that in 2009?
Give a very brief answer. 1.07. What is the ratio of the Tax (as % of total tax revenue) of Uganda in 2008 to that in 2009?
Ensure brevity in your answer.  0.97. What is the ratio of the Tax (as % of total tax revenue) in United States in 2008 to that in 2009?
Offer a very short reply. 1.01. What is the ratio of the Tax (as % of total tax revenue) in New Zealand in 2008 to that in 2010?
Provide a short and direct response. 1.13. What is the ratio of the Tax (as % of total tax revenue) in Qatar in 2008 to that in 2010?
Ensure brevity in your answer.  1.01. What is the ratio of the Tax (as % of total tax revenue) of Uganda in 2008 to that in 2010?
Your response must be concise. 0.88. What is the ratio of the Tax (as % of total tax revenue) in United States in 2008 to that in 2010?
Offer a very short reply. 1. What is the ratio of the Tax (as % of total tax revenue) in New Zealand in 2009 to that in 2010?
Your response must be concise. 1.06. What is the ratio of the Tax (as % of total tax revenue) of Qatar in 2009 to that in 2010?
Your response must be concise. 1.02. What is the ratio of the Tax (as % of total tax revenue) of Uganda in 2009 to that in 2010?
Provide a short and direct response. 0.91. What is the difference between the highest and the second highest Tax (as % of total tax revenue) in New Zealand?
Offer a terse response. 1.05. What is the difference between the highest and the second highest Tax (as % of total tax revenue) in Qatar?
Provide a succinct answer. 0.29. What is the difference between the highest and the second highest Tax (as % of total tax revenue) of Uganda?
Your answer should be very brief. 2.89. What is the difference between the highest and the second highest Tax (as % of total tax revenue) of United States?
Make the answer very short. 0.72. What is the difference between the highest and the lowest Tax (as % of total tax revenue) in New Zealand?
Ensure brevity in your answer.  7.94. What is the difference between the highest and the lowest Tax (as % of total tax revenue) in Qatar?
Make the answer very short. 2.5. What is the difference between the highest and the lowest Tax (as % of total tax revenue) in Uganda?
Give a very brief answer. 6.47. What is the difference between the highest and the lowest Tax (as % of total tax revenue) of United States?
Make the answer very short. 2.89. 